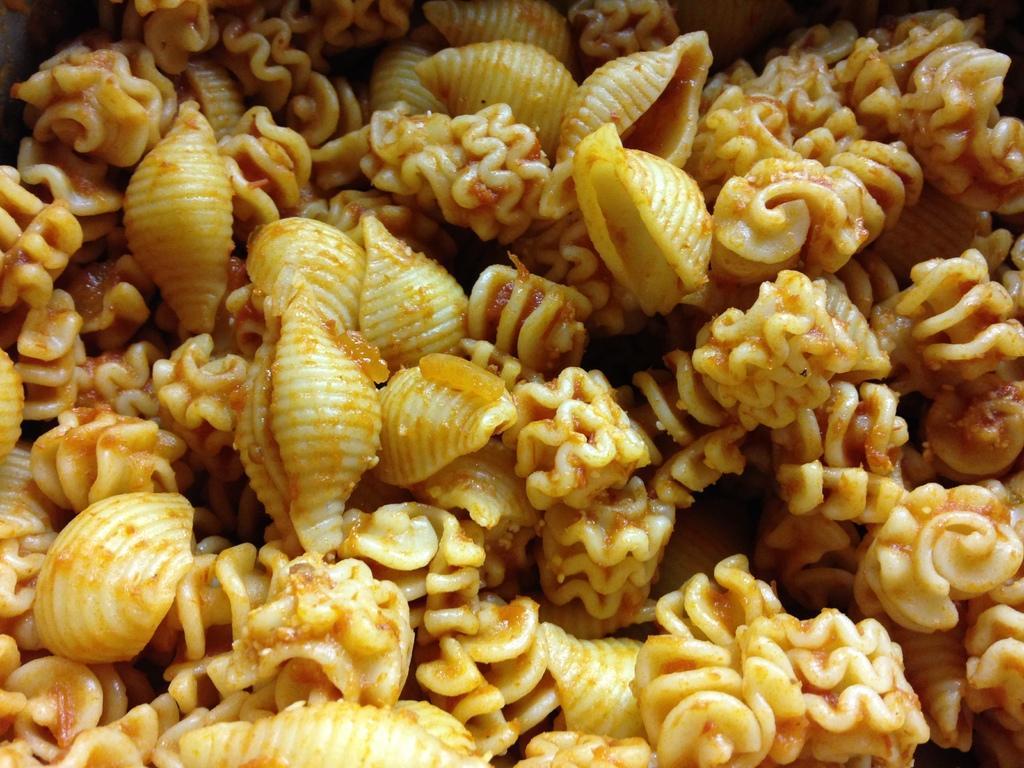Can you describe this image briefly? In this picture I can see the food. 